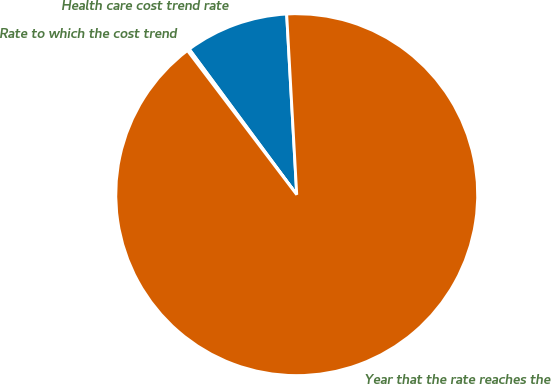Convert chart. <chart><loc_0><loc_0><loc_500><loc_500><pie_chart><fcel>Health care cost trend rate<fcel>Rate to which the cost trend<fcel>Year that the rate reaches the<nl><fcel>9.24%<fcel>0.2%<fcel>90.56%<nl></chart> 